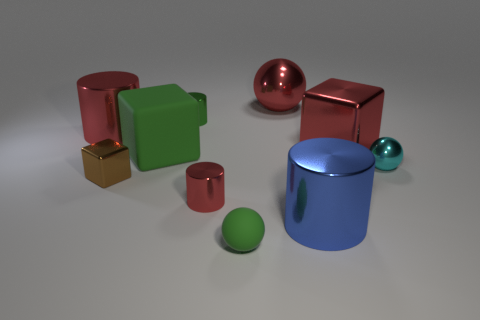What is the material of the green block that is the same size as the red metallic cube?
Provide a succinct answer. Rubber. There is a red object that is to the left of the metal cube that is in front of the cyan metallic thing; is there a tiny cylinder on the right side of it?
Make the answer very short. Yes. There is a big metallic thing on the left side of the tiny green sphere; is it the same color as the metallic ball that is behind the cyan shiny ball?
Your answer should be compact. Yes. Are there any small blue metallic spheres?
Provide a short and direct response. No. What is the material of the large cube that is the same color as the tiny rubber ball?
Ensure brevity in your answer.  Rubber. There is a shiny ball that is behind the small sphere on the right side of the green matte thing that is in front of the big rubber block; how big is it?
Offer a very short reply. Large. Do the blue metal thing and the tiny green object that is behind the large blue metal thing have the same shape?
Give a very brief answer. Yes. Is there a tiny shiny cylinder that has the same color as the big sphere?
Give a very brief answer. Yes. What number of cylinders are either large brown objects or large green objects?
Ensure brevity in your answer.  0. Are there any red objects of the same shape as the cyan metal thing?
Your answer should be compact. Yes. 